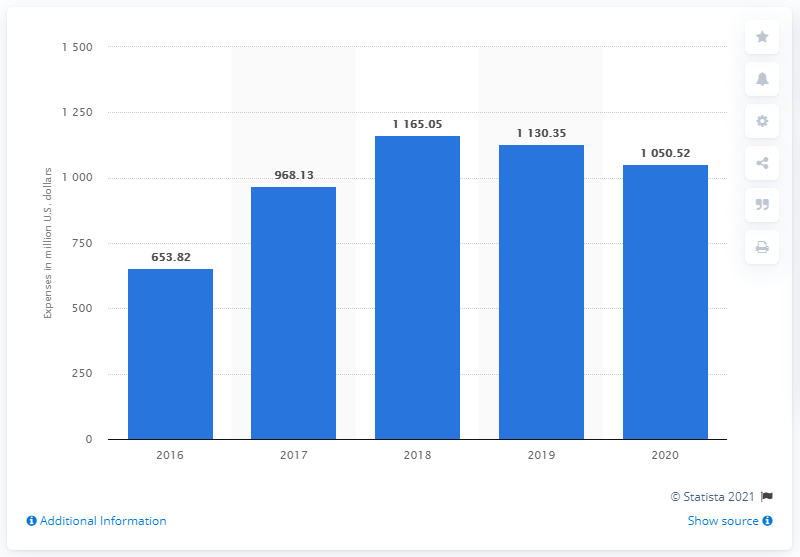Indicate a few pertinent items in this graphic. The year with the largest decrease in R&D expenses was 2020. Analog Devices reported spending $1050.52 million on research and development in 2020. The median value of the bars is 1050.52. 